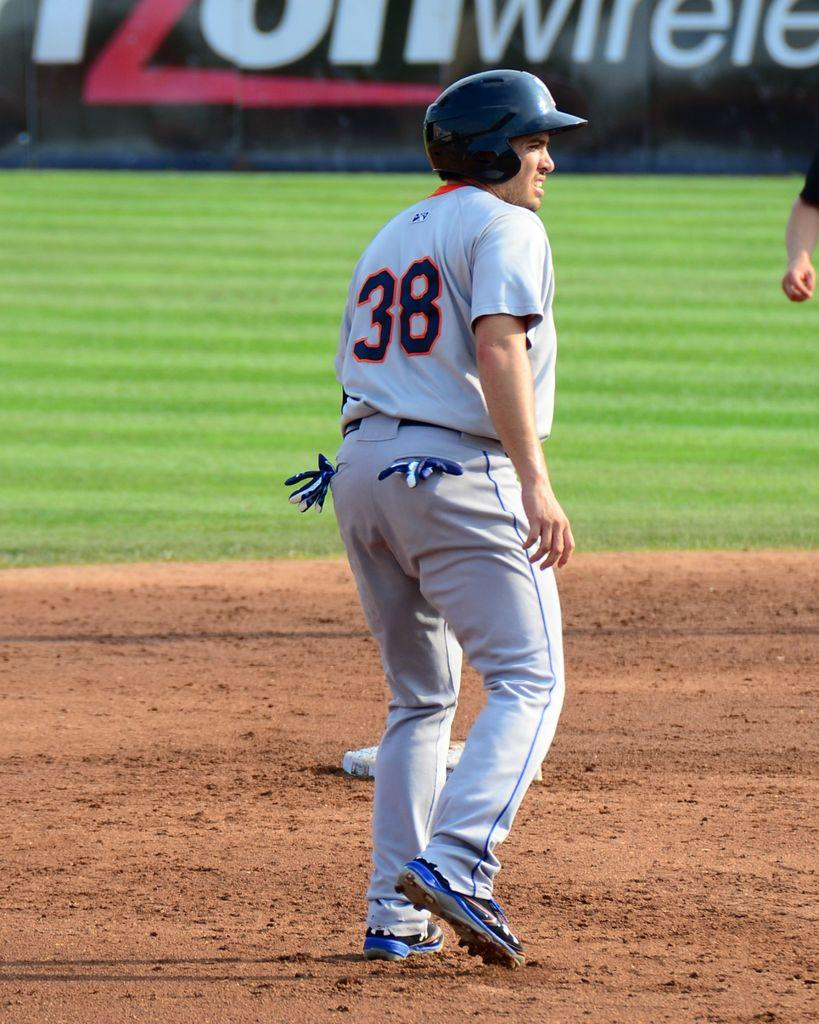What is the main subject of the image? There is a person standing in the center of the image. What is the person's position relative to the ground? The person is standing on the ground. What type of vegetation can be seen in the background of the image? There is grass visible in the background of the image. How many grapes can be seen hanging from the person's back in the image? There are no grapes present in the image, and the person's back is not visible. 